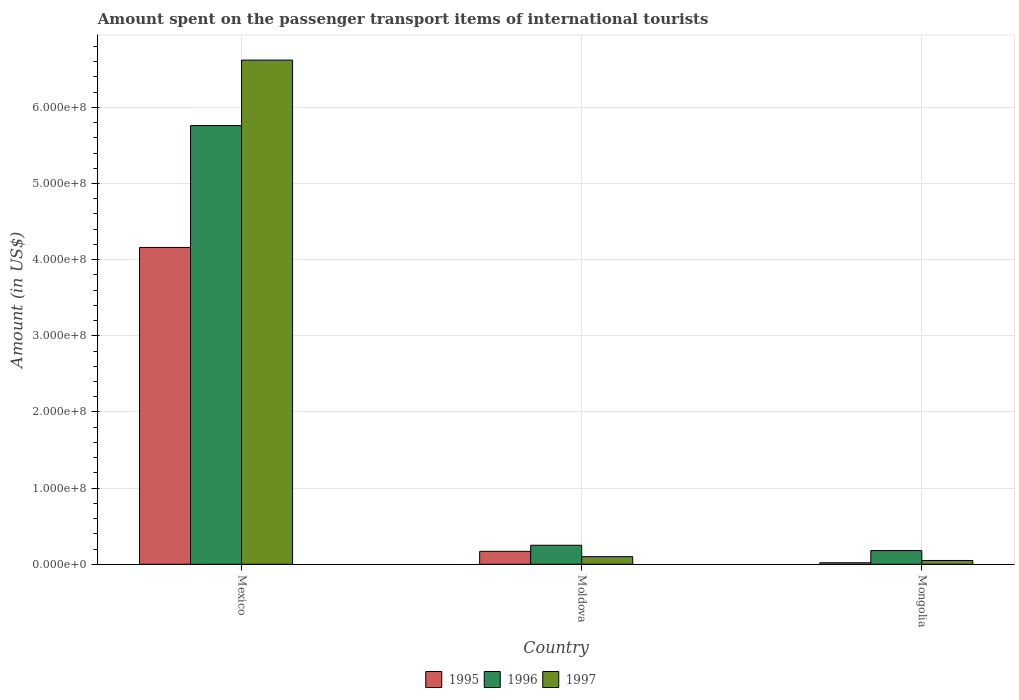How many different coloured bars are there?
Provide a succinct answer. 3. Are the number of bars on each tick of the X-axis equal?
Ensure brevity in your answer.  Yes. How many bars are there on the 1st tick from the left?
Ensure brevity in your answer.  3. How many bars are there on the 2nd tick from the right?
Provide a succinct answer. 3. What is the label of the 2nd group of bars from the left?
Give a very brief answer. Moldova. In how many cases, is the number of bars for a given country not equal to the number of legend labels?
Ensure brevity in your answer.  0. Across all countries, what is the maximum amount spent on the passenger transport items of international tourists in 1996?
Your response must be concise. 5.76e+08. Across all countries, what is the minimum amount spent on the passenger transport items of international tourists in 1995?
Make the answer very short. 2.00e+06. In which country was the amount spent on the passenger transport items of international tourists in 1997 minimum?
Provide a short and direct response. Mongolia. What is the total amount spent on the passenger transport items of international tourists in 1995 in the graph?
Keep it short and to the point. 4.35e+08. What is the difference between the amount spent on the passenger transport items of international tourists in 1996 in Moldova and that in Mongolia?
Give a very brief answer. 7.00e+06. What is the difference between the amount spent on the passenger transport items of international tourists in 1997 in Mexico and the amount spent on the passenger transport items of international tourists in 1996 in Mongolia?
Your answer should be very brief. 6.44e+08. What is the average amount spent on the passenger transport items of international tourists in 1995 per country?
Provide a succinct answer. 1.45e+08. What is the difference between the amount spent on the passenger transport items of international tourists of/in 1995 and amount spent on the passenger transport items of international tourists of/in 1996 in Mexico?
Your answer should be very brief. -1.60e+08. What is the ratio of the amount spent on the passenger transport items of international tourists in 1995 in Mexico to that in Moldova?
Make the answer very short. 24.47. Is the amount spent on the passenger transport items of international tourists in 1997 in Mexico less than that in Moldova?
Keep it short and to the point. No. What is the difference between the highest and the second highest amount spent on the passenger transport items of international tourists in 1996?
Ensure brevity in your answer.  5.51e+08. What is the difference between the highest and the lowest amount spent on the passenger transport items of international tourists in 1995?
Your response must be concise. 4.14e+08. What does the 1st bar from the right in Mongolia represents?
Provide a succinct answer. 1997. Are all the bars in the graph horizontal?
Your answer should be very brief. No. Are the values on the major ticks of Y-axis written in scientific E-notation?
Keep it short and to the point. Yes. Does the graph contain any zero values?
Your answer should be compact. No. Does the graph contain grids?
Offer a terse response. Yes. What is the title of the graph?
Provide a succinct answer. Amount spent on the passenger transport items of international tourists. What is the label or title of the X-axis?
Your answer should be compact. Country. What is the Amount (in US$) in 1995 in Mexico?
Offer a terse response. 4.16e+08. What is the Amount (in US$) in 1996 in Mexico?
Provide a short and direct response. 5.76e+08. What is the Amount (in US$) in 1997 in Mexico?
Your response must be concise. 6.62e+08. What is the Amount (in US$) in 1995 in Moldova?
Keep it short and to the point. 1.70e+07. What is the Amount (in US$) in 1996 in Moldova?
Keep it short and to the point. 2.50e+07. What is the Amount (in US$) in 1995 in Mongolia?
Your response must be concise. 2.00e+06. What is the Amount (in US$) of 1996 in Mongolia?
Your response must be concise. 1.80e+07. What is the Amount (in US$) in 1997 in Mongolia?
Keep it short and to the point. 5.00e+06. Across all countries, what is the maximum Amount (in US$) of 1995?
Your answer should be compact. 4.16e+08. Across all countries, what is the maximum Amount (in US$) of 1996?
Your answer should be very brief. 5.76e+08. Across all countries, what is the maximum Amount (in US$) of 1997?
Make the answer very short. 6.62e+08. Across all countries, what is the minimum Amount (in US$) in 1995?
Your response must be concise. 2.00e+06. Across all countries, what is the minimum Amount (in US$) of 1996?
Ensure brevity in your answer.  1.80e+07. Across all countries, what is the minimum Amount (in US$) of 1997?
Offer a terse response. 5.00e+06. What is the total Amount (in US$) of 1995 in the graph?
Provide a short and direct response. 4.35e+08. What is the total Amount (in US$) in 1996 in the graph?
Offer a terse response. 6.19e+08. What is the total Amount (in US$) in 1997 in the graph?
Give a very brief answer. 6.77e+08. What is the difference between the Amount (in US$) of 1995 in Mexico and that in Moldova?
Your answer should be very brief. 3.99e+08. What is the difference between the Amount (in US$) in 1996 in Mexico and that in Moldova?
Offer a terse response. 5.51e+08. What is the difference between the Amount (in US$) in 1997 in Mexico and that in Moldova?
Give a very brief answer. 6.52e+08. What is the difference between the Amount (in US$) in 1995 in Mexico and that in Mongolia?
Keep it short and to the point. 4.14e+08. What is the difference between the Amount (in US$) of 1996 in Mexico and that in Mongolia?
Ensure brevity in your answer.  5.58e+08. What is the difference between the Amount (in US$) of 1997 in Mexico and that in Mongolia?
Give a very brief answer. 6.57e+08. What is the difference between the Amount (in US$) in 1995 in Moldova and that in Mongolia?
Keep it short and to the point. 1.50e+07. What is the difference between the Amount (in US$) in 1995 in Mexico and the Amount (in US$) in 1996 in Moldova?
Keep it short and to the point. 3.91e+08. What is the difference between the Amount (in US$) of 1995 in Mexico and the Amount (in US$) of 1997 in Moldova?
Provide a short and direct response. 4.06e+08. What is the difference between the Amount (in US$) in 1996 in Mexico and the Amount (in US$) in 1997 in Moldova?
Your response must be concise. 5.66e+08. What is the difference between the Amount (in US$) of 1995 in Mexico and the Amount (in US$) of 1996 in Mongolia?
Provide a succinct answer. 3.98e+08. What is the difference between the Amount (in US$) of 1995 in Mexico and the Amount (in US$) of 1997 in Mongolia?
Your answer should be very brief. 4.11e+08. What is the difference between the Amount (in US$) in 1996 in Mexico and the Amount (in US$) in 1997 in Mongolia?
Keep it short and to the point. 5.71e+08. What is the difference between the Amount (in US$) in 1995 in Moldova and the Amount (in US$) in 1997 in Mongolia?
Give a very brief answer. 1.20e+07. What is the average Amount (in US$) of 1995 per country?
Keep it short and to the point. 1.45e+08. What is the average Amount (in US$) of 1996 per country?
Provide a succinct answer. 2.06e+08. What is the average Amount (in US$) of 1997 per country?
Provide a short and direct response. 2.26e+08. What is the difference between the Amount (in US$) of 1995 and Amount (in US$) of 1996 in Mexico?
Provide a short and direct response. -1.60e+08. What is the difference between the Amount (in US$) in 1995 and Amount (in US$) in 1997 in Mexico?
Your answer should be compact. -2.46e+08. What is the difference between the Amount (in US$) of 1996 and Amount (in US$) of 1997 in Mexico?
Give a very brief answer. -8.60e+07. What is the difference between the Amount (in US$) of 1995 and Amount (in US$) of 1996 in Moldova?
Offer a very short reply. -8.00e+06. What is the difference between the Amount (in US$) in 1996 and Amount (in US$) in 1997 in Moldova?
Give a very brief answer. 1.50e+07. What is the difference between the Amount (in US$) of 1995 and Amount (in US$) of 1996 in Mongolia?
Your answer should be very brief. -1.60e+07. What is the difference between the Amount (in US$) in 1995 and Amount (in US$) in 1997 in Mongolia?
Offer a terse response. -3.00e+06. What is the difference between the Amount (in US$) of 1996 and Amount (in US$) of 1997 in Mongolia?
Keep it short and to the point. 1.30e+07. What is the ratio of the Amount (in US$) in 1995 in Mexico to that in Moldova?
Provide a short and direct response. 24.47. What is the ratio of the Amount (in US$) in 1996 in Mexico to that in Moldova?
Keep it short and to the point. 23.04. What is the ratio of the Amount (in US$) of 1997 in Mexico to that in Moldova?
Your response must be concise. 66.2. What is the ratio of the Amount (in US$) in 1995 in Mexico to that in Mongolia?
Offer a terse response. 208. What is the ratio of the Amount (in US$) of 1996 in Mexico to that in Mongolia?
Give a very brief answer. 32. What is the ratio of the Amount (in US$) of 1997 in Mexico to that in Mongolia?
Provide a short and direct response. 132.4. What is the ratio of the Amount (in US$) of 1996 in Moldova to that in Mongolia?
Your response must be concise. 1.39. What is the ratio of the Amount (in US$) of 1997 in Moldova to that in Mongolia?
Give a very brief answer. 2. What is the difference between the highest and the second highest Amount (in US$) in 1995?
Provide a short and direct response. 3.99e+08. What is the difference between the highest and the second highest Amount (in US$) in 1996?
Provide a succinct answer. 5.51e+08. What is the difference between the highest and the second highest Amount (in US$) of 1997?
Keep it short and to the point. 6.52e+08. What is the difference between the highest and the lowest Amount (in US$) of 1995?
Offer a terse response. 4.14e+08. What is the difference between the highest and the lowest Amount (in US$) of 1996?
Your answer should be very brief. 5.58e+08. What is the difference between the highest and the lowest Amount (in US$) in 1997?
Give a very brief answer. 6.57e+08. 